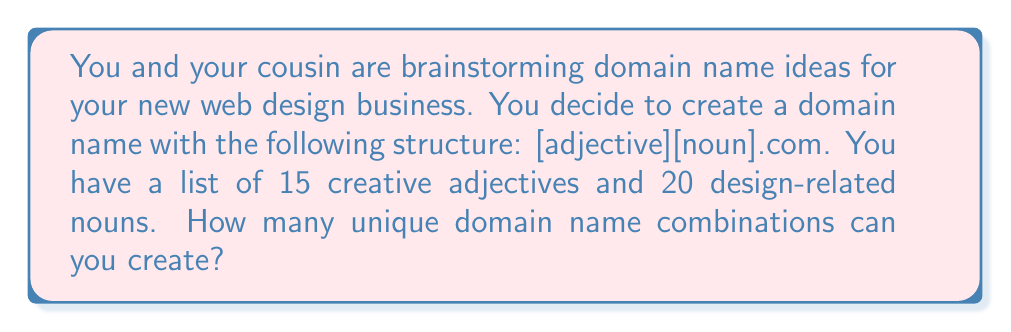Show me your answer to this math problem. To solve this problem, we need to use the multiplication principle of counting. The domain name structure has two components:

1. An adjective (15 choices)
2. A noun (20 choices)

Each component can be chosen independently of the other. According to the multiplication principle, when we have multiple independent choices, we multiply the number of options for each choice to get the total number of possible combinations.

Let's break it down step-by-step:

1. Number of adjective choices: 15
2. Number of noun choices: 20

To calculate the total number of unique domain name combinations:

$$\text{Total combinations} = \text{Number of adjectives} \times \text{Number of nouns}$$

$$\text{Total combinations} = 15 \times 20 = 300$$

Therefore, you can create 300 unique domain name combinations using the given structure and available options.
Answer: $300$ unique domain name combinations 